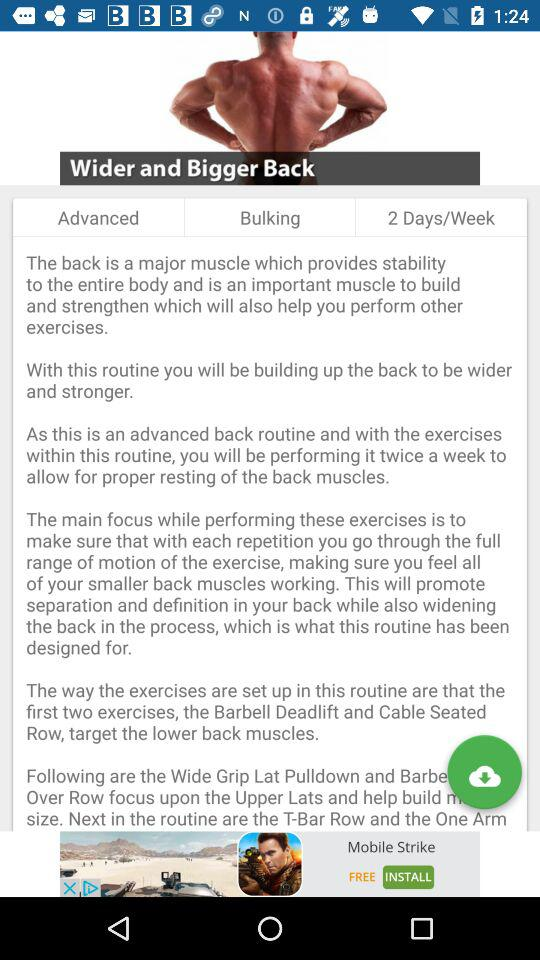How many exercises are required for bulking up 2 days a week?
When the provided information is insufficient, respond with <no answer>. <no answer> 